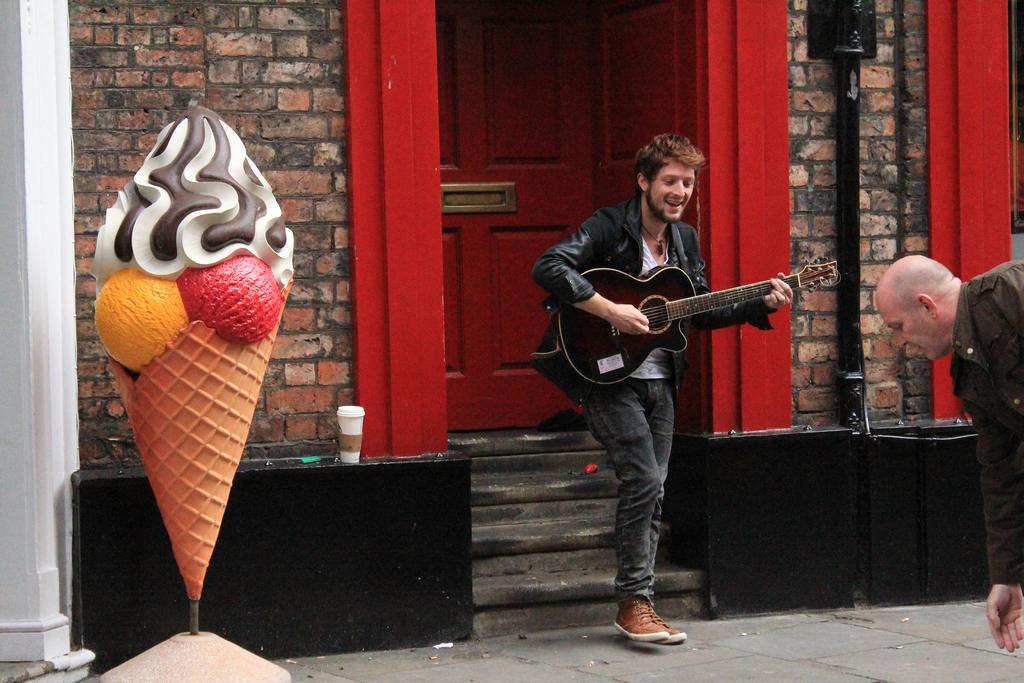What is the man in the image doing? The man is standing and smiling while playing a guitar. Where is the scene taking place? The scene takes place in a street. Can you describe the background of the image? There is another person, a door, a building, an ice cream, a pole, and a glass visible in the background. How many people are present in the image? There is one man playing the guitar and another person in the background, making a total of two people. What type of crime is taking place in the image? There is no indication of any crime taking place in the image. The man is playing a guitar, and the scene appears to be a peaceful one. 